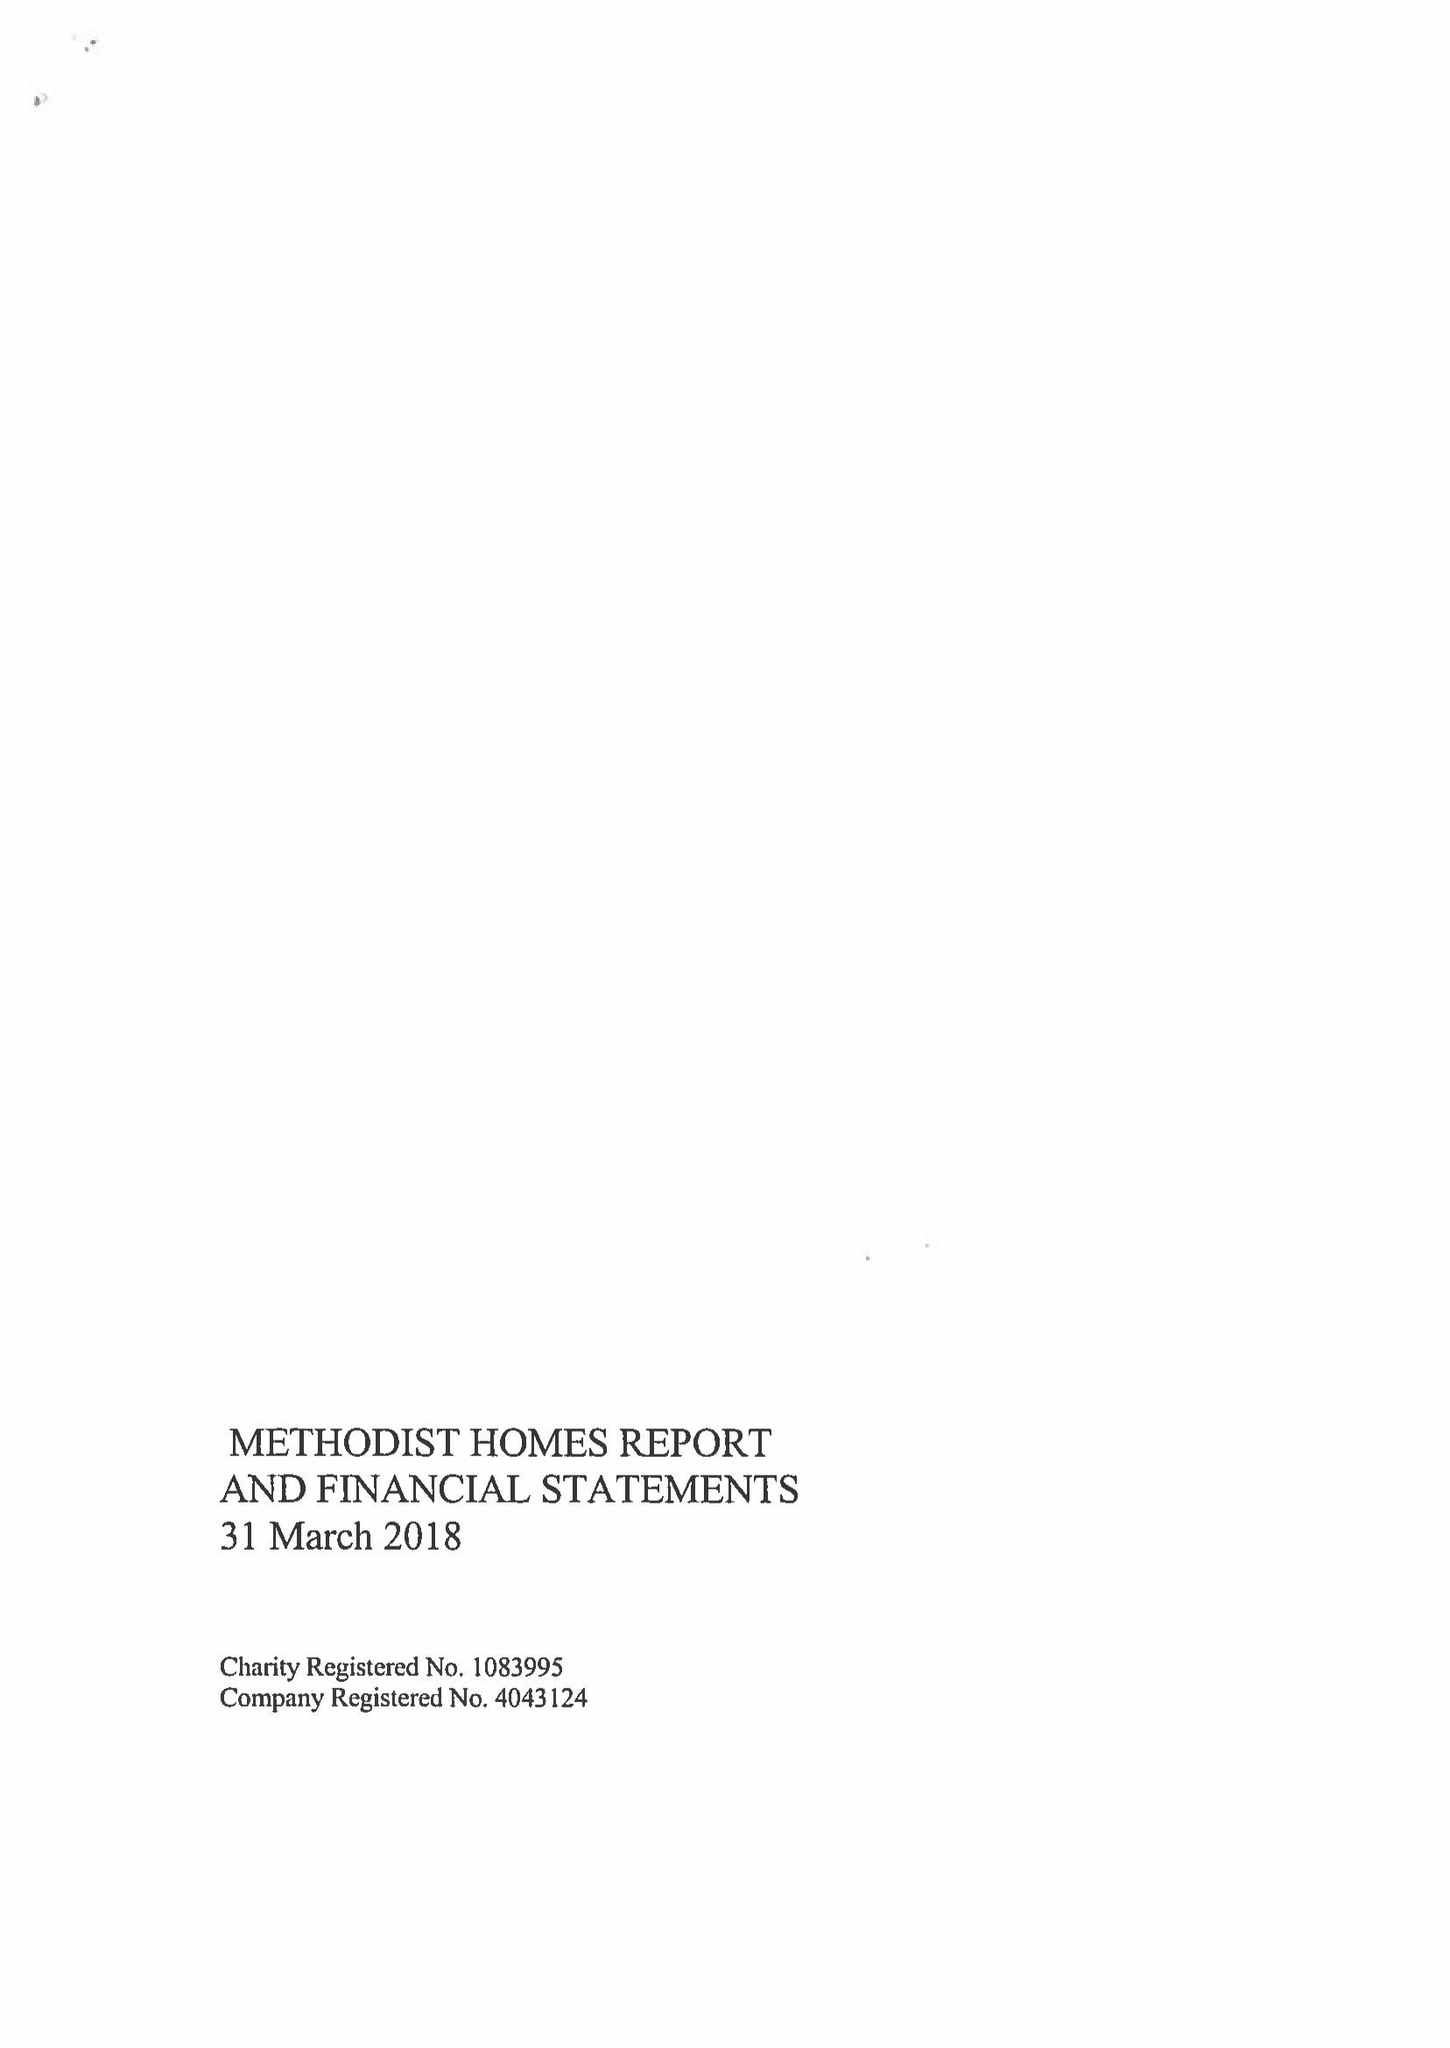What is the value for the report_date?
Answer the question using a single word or phrase. 2018-03-31 